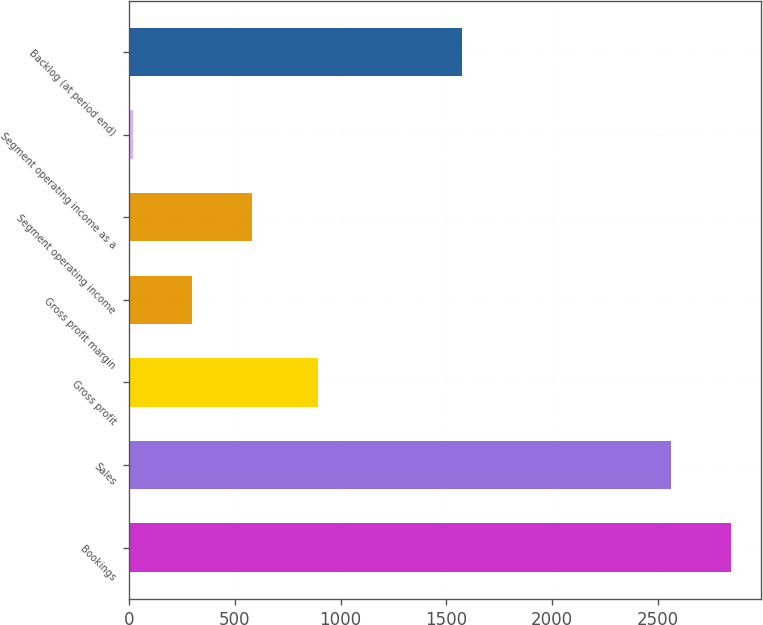<chart> <loc_0><loc_0><loc_500><loc_500><bar_chart><fcel>Bookings<fcel>Sales<fcel>Gross profit<fcel>Gross profit margin<fcel>Segment operating income<fcel>Segment operating income as a<fcel>Backlog (at period end)<nl><fcel>2846.14<fcel>2564.6<fcel>892.5<fcel>298.94<fcel>580.48<fcel>17.4<fcel>1573.3<nl></chart> 